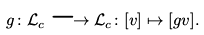<formula> <loc_0><loc_0><loc_500><loc_500>g \colon \mathcal { L } _ { c } \longrightarrow \mathcal { L } _ { c } \colon [ v ] \mapsto [ g v ] .</formula> 